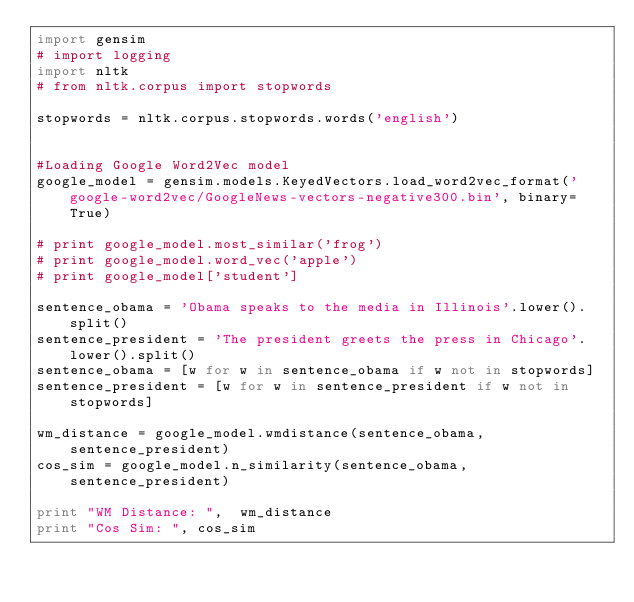<code> <loc_0><loc_0><loc_500><loc_500><_Python_>import gensim
# import logging
import nltk
# from nltk.corpus import stopwords

stopwords = nltk.corpus.stopwords.words('english')


#Loading Google Word2Vec model
google_model = gensim.models.KeyedVectors.load_word2vec_format('google-word2vec/GoogleNews-vectors-negative300.bin', binary=True)

# print google_model.most_similar('frog')
# print google_model.word_vec('apple')
# print google_model['student']

sentence_obama = 'Obama speaks to the media in Illinois'.lower().split()
sentence_president = 'The president greets the press in Chicago'.lower().split()
sentence_obama = [w for w in sentence_obama if w not in stopwords]
sentence_president = [w for w in sentence_president if w not in stopwords]

wm_distance = google_model.wmdistance(sentence_obama, sentence_president)
cos_sim = google_model.n_similarity(sentence_obama, sentence_president)

print "WM Distance: ",  wm_distance
print "Cos Sim: ", cos_sim
</code> 